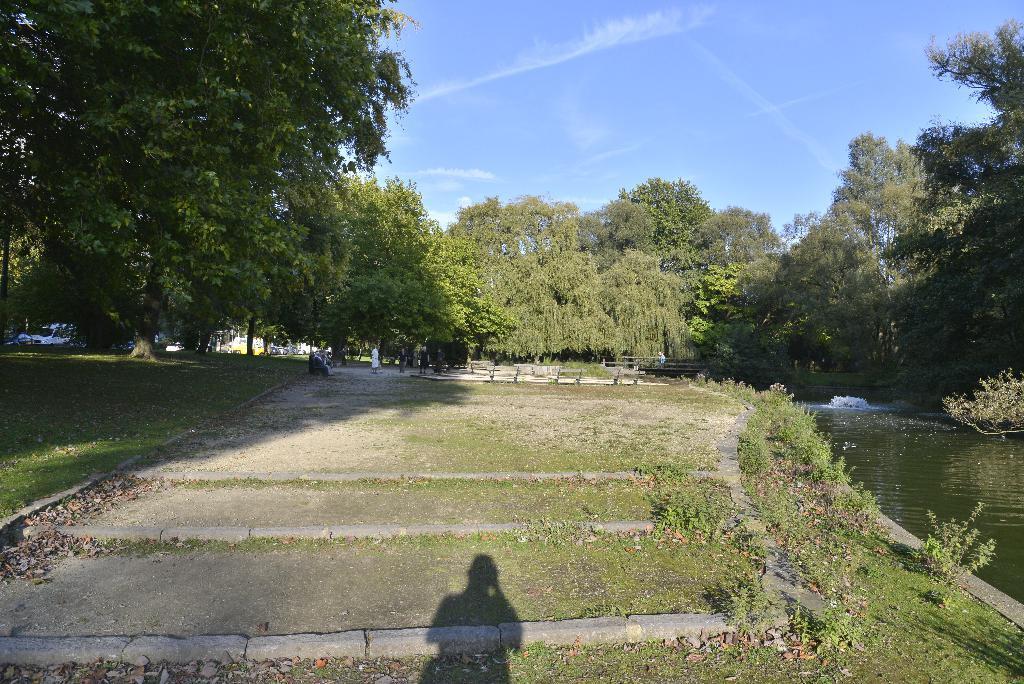Can you describe this image briefly? This picture shows few trees and we see plants and few benches and grass on the ground and we see a shadow of a human and we see water and a blue cloudy sky. 